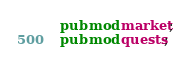<code> <loc_0><loc_0><loc_500><loc_500><_Rust_>pub mod market;
pub mod quests;
</code> 